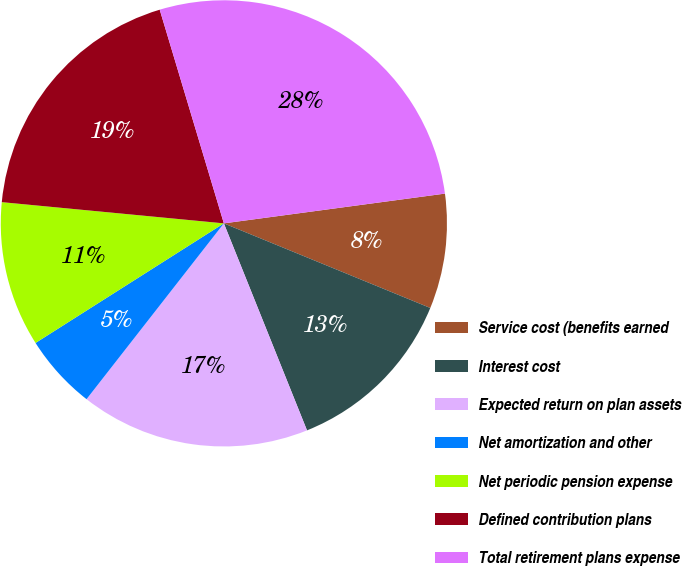Convert chart to OTSL. <chart><loc_0><loc_0><loc_500><loc_500><pie_chart><fcel>Service cost (benefits earned<fcel>Interest cost<fcel>Expected return on plan assets<fcel>Net amortization and other<fcel>Net periodic pension expense<fcel>Defined contribution plans<fcel>Total retirement plans expense<nl><fcel>8.32%<fcel>12.73%<fcel>16.63%<fcel>5.44%<fcel>10.52%<fcel>18.84%<fcel>27.51%<nl></chart> 